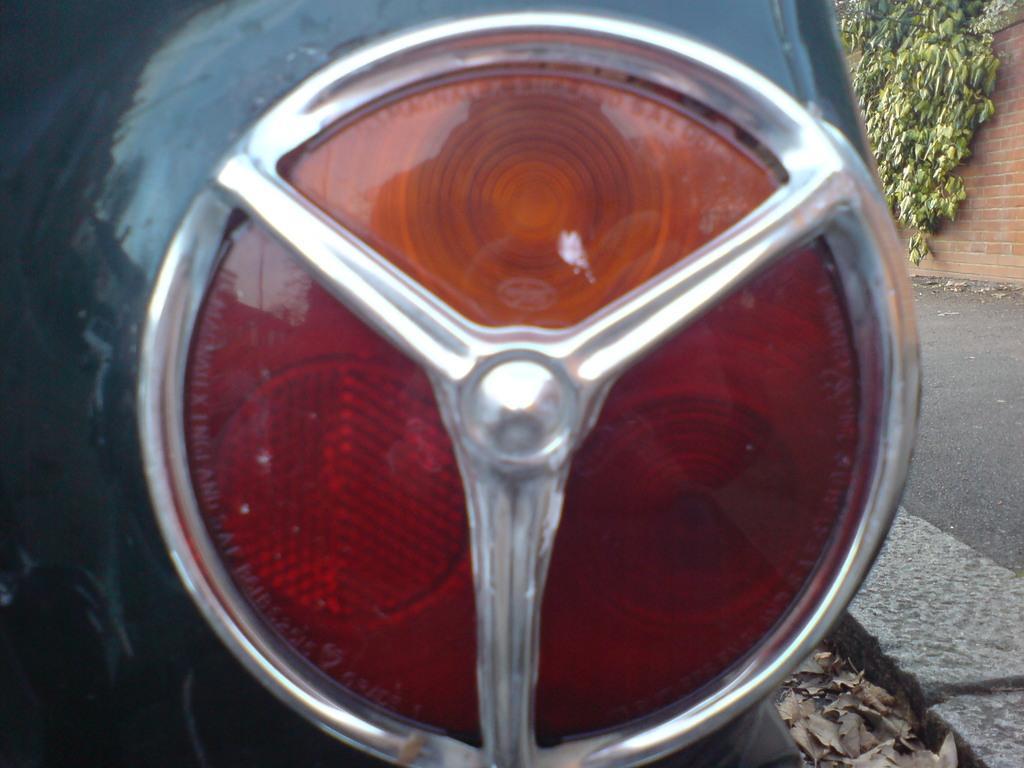In one or two sentences, can you explain what this image depicts? In this image there is a vehicle having a light. Right side there is a pavement. Beside there is a wall having few creepers on it. Few dried leaves are beside the pavement. 